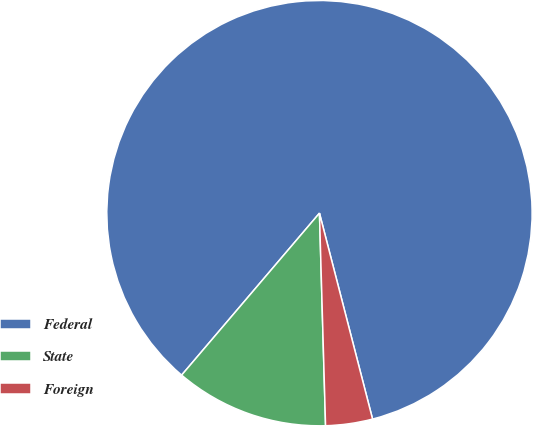Convert chart to OTSL. <chart><loc_0><loc_0><loc_500><loc_500><pie_chart><fcel>Federal<fcel>State<fcel>Foreign<nl><fcel>84.77%<fcel>11.68%<fcel>3.56%<nl></chart> 